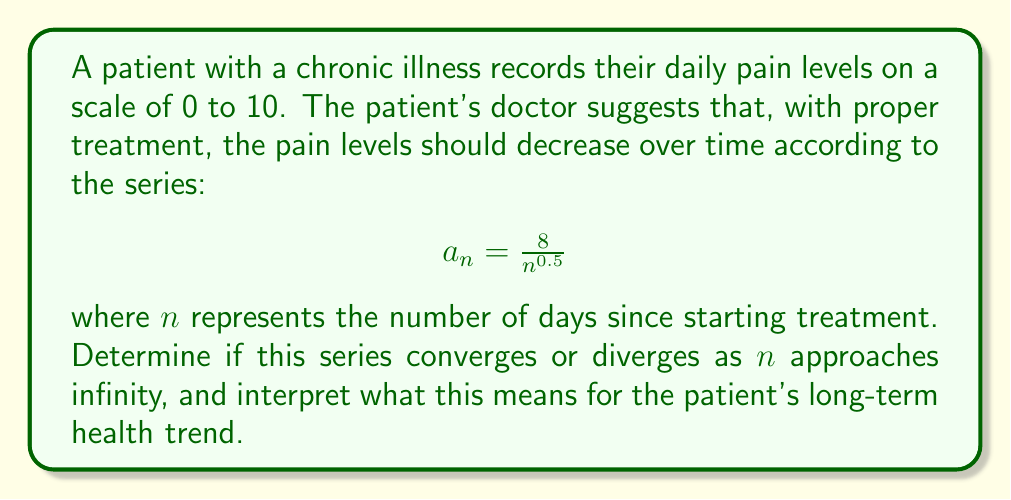Could you help me with this problem? To analyze the behavior of this infinite series, we'll use the p-series test:

1) The general form of a p-series is $\sum_{n=1}^{\infty} \frac{1}{n^p}$

2) Our series can be rewritten as: $\sum_{n=1}^{\infty} \frac{8}{n^{0.5}} = 8 \sum_{n=1}^{\infty} \frac{1}{n^{0.5}}$

3) In this case, $p = 0.5$

4) The p-series test states:
   - If $p > 1$, the series converges
   - If $p \leq 1$, the series diverges

5) Since $p = 0.5 < 1$, the series diverges

Interpretation for the patient:
The divergence of the series implies that the sum of the pain levels over time goes to infinity. However, this doesn't mean the pain is increasing. Each term $a_n = \frac{8}{n^{0.5}}$ is decreasing as $n$ increases, meaning daily pain levels are reducing.

The divergence indicates that while pain levels decrease each day, they do so at a rate that's not fast enough for the total cumulative pain (sum of all daily pain levels) to reach a finite value. In practical terms, this suggests a gradual, long-term improvement in the patient's condition, but with persistent, albeit decreasing, levels of daily pain.
Answer: The series diverges, indicating gradual pain reduction but persistent long-term symptoms. 